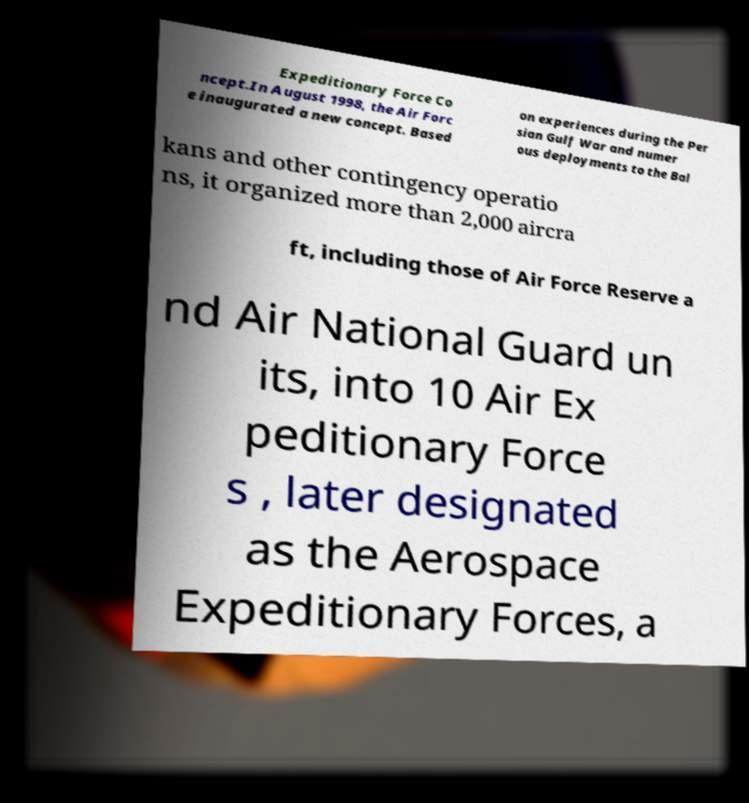Can you accurately transcribe the text from the provided image for me? Expeditionary Force Co ncept.In August 1998, the Air Forc e inaugurated a new concept. Based on experiences during the Per sian Gulf War and numer ous deployments to the Bal kans and other contingency operatio ns, it organized more than 2,000 aircra ft, including those of Air Force Reserve a nd Air National Guard un its, into 10 Air Ex peditionary Force s , later designated as the Aerospace Expeditionary Forces, a 